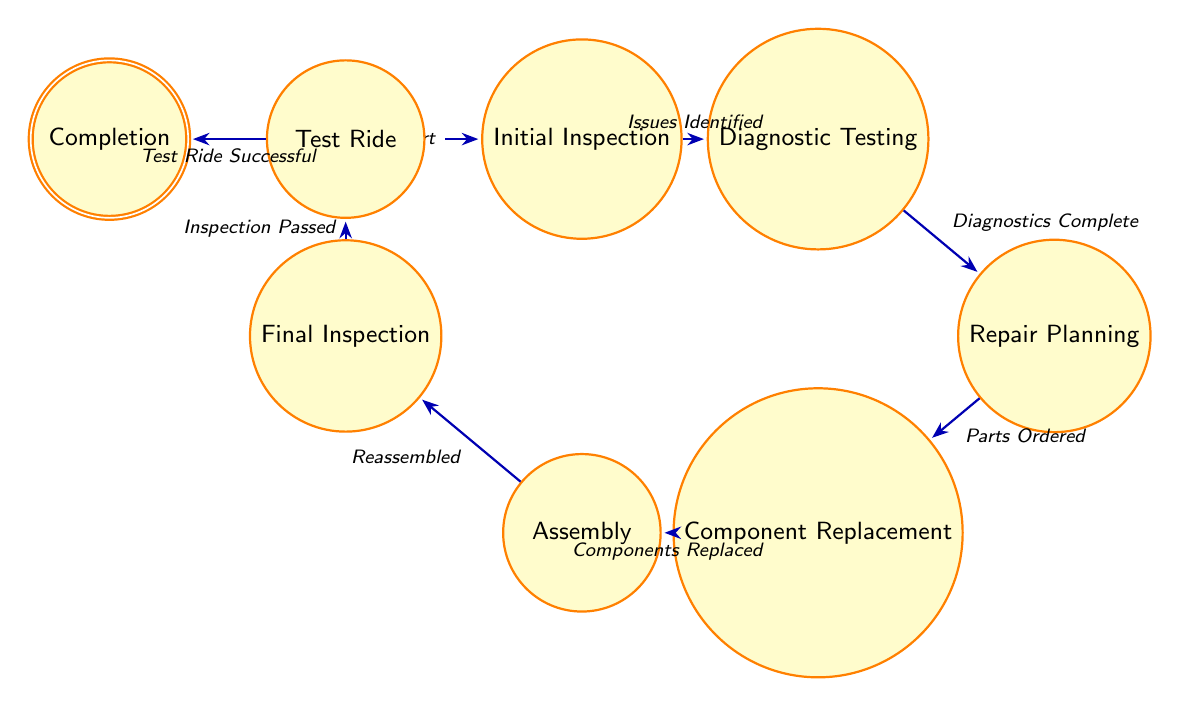What is the first state in the diagram? The first state, indicated in the diagram, is the "Initial Inspection," which signifies the starting point for the motorcycle maintenance and repair process.
Answer: Initial Inspection How many total states are there? The diagram lists a total of eight distinct states involved in the motorcycle maintenance and repair process.
Answer: Eight What action triggers the transition from Diagnostic Testing to Repair Planning? The transition between these two states is triggered by the action "Diagnostics Complete," indicating that once diagnostics are finished, the next step is planning repairs.
Answer: Diagnostics Complete What is the last state in the sequence? The diagram shows that "Completion" is the last state, marking the end of the motorcycle maintenance and repair process when all work is confirmed as finished.
Answer: Completion Which state precedes Component Replacement? The state that precedes "Component Replacement" is "Repair Planning," meaning that after planning, the next step is to replace the necessary parts.
Answer: Repair Planning What is the action associated with moving from Assembly to Final Inspection? The action required to transition from "Assembly" to "Final Inspection" is "Reassembled," which indicates that all components must be put back together before the final check.
Answer: Reassembled How many transitions are there in total? The diagram has eight transitions connecting the different states, representing the workflows between each step in the motorcycle repair process.
Answer: Seven What state leads to Test Ride? The state that leads to "Test Ride" is "Final Inspection," which confirms that all repairs have passed their final checks before the test ride takes place.
Answer: Final Inspection What is the action that follows Component Replacement? The action that follows "Component Replacement" is "Assembly," indicating that after parts are replaced, they must be reassembled into the motorcycle.
Answer: Assembly 